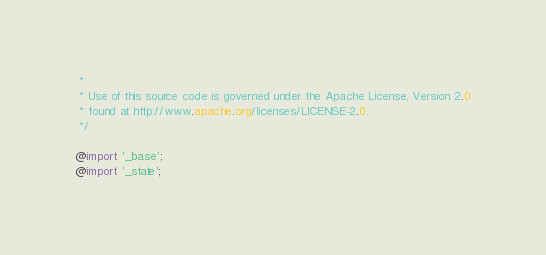Convert code to text. <code><loc_0><loc_0><loc_500><loc_500><_CSS_> *
 * Use of this source code is governed under the Apache License, Version 2.0
 * found at http://www.apache.org/licenses/LICENSE-2.0.
 */

@import '_base';
@import '_state';
</code> 